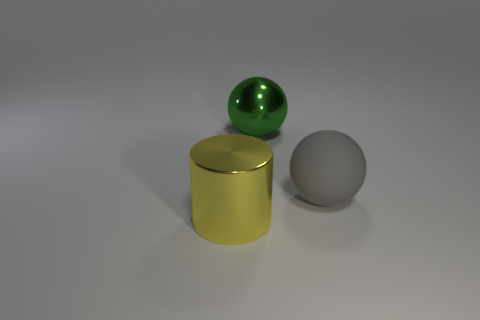Subtract 1 balls. How many balls are left? 1 Subtract all gray balls. How many balls are left? 1 Add 3 balls. How many objects exist? 6 Subtract all red cylinders. Subtract all blue cubes. How many cylinders are left? 1 Subtract all blue cylinders. How many green balls are left? 1 Subtract all large green balls. Subtract all cyan metallic balls. How many objects are left? 2 Add 1 large shiny balls. How many large shiny balls are left? 2 Add 3 big matte objects. How many big matte objects exist? 4 Subtract 0 purple balls. How many objects are left? 3 Subtract all cylinders. How many objects are left? 2 